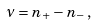<formula> <loc_0><loc_0><loc_500><loc_500>\nu = n _ { + } - n _ { - } \, ,</formula> 